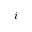<formula> <loc_0><loc_0><loc_500><loc_500>i</formula> 